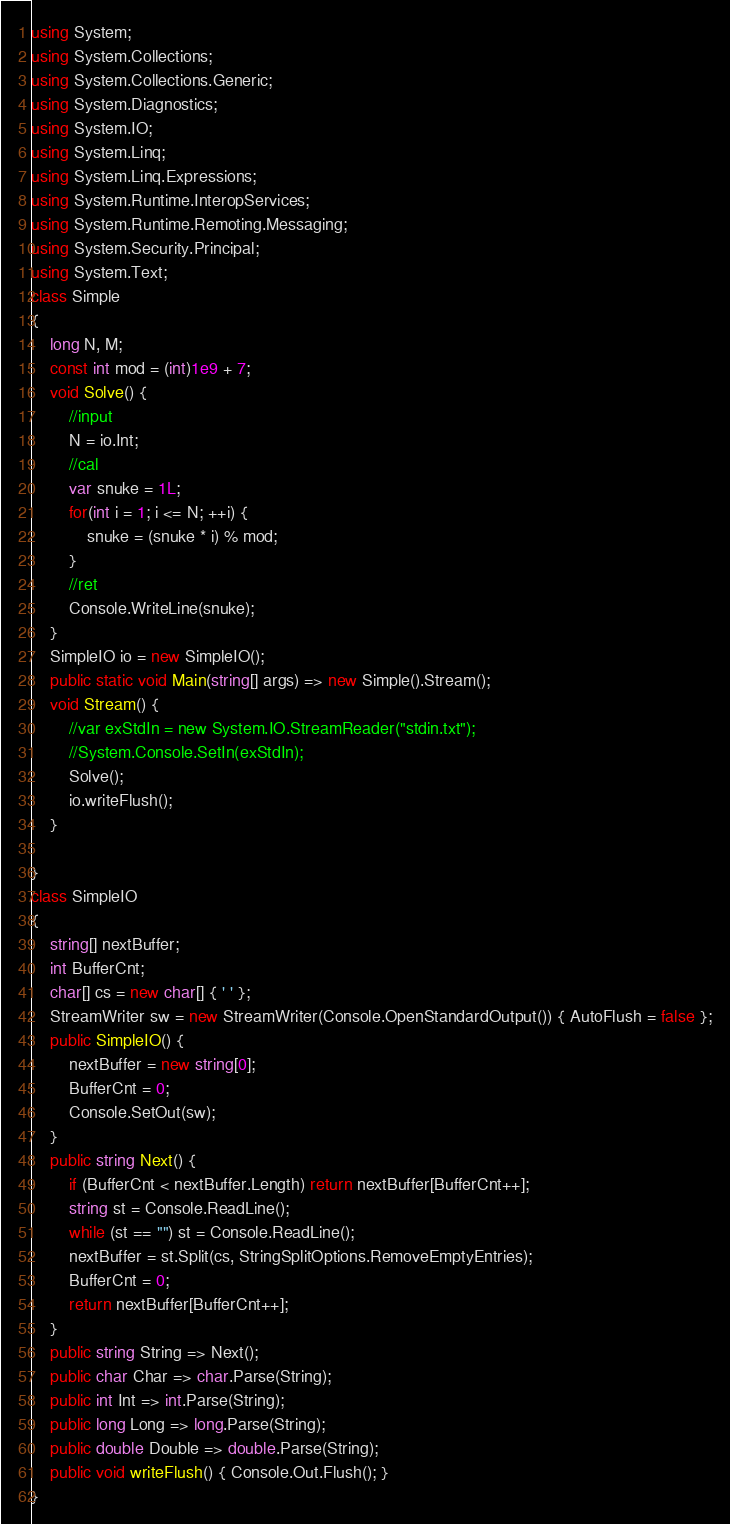Convert code to text. <code><loc_0><loc_0><loc_500><loc_500><_C#_>using System;
using System.Collections;
using System.Collections.Generic;
using System.Diagnostics;
using System.IO;
using System.Linq;
using System.Linq.Expressions;
using System.Runtime.InteropServices;
using System.Runtime.Remoting.Messaging;
using System.Security.Principal;
using System.Text;
class Simple
{
    long N, M;
    const int mod = (int)1e9 + 7;
    void Solve() {
        //input
        N = io.Int;
        //cal
        var snuke = 1L;
        for(int i = 1; i <= N; ++i) {
            snuke = (snuke * i) % mod;
        }
        //ret
        Console.WriteLine(snuke);
    }
    SimpleIO io = new SimpleIO();
    public static void Main(string[] args) => new Simple().Stream();
    void Stream() {
        //var exStdIn = new System.IO.StreamReader("stdin.txt");
        //System.Console.SetIn(exStdIn);
        Solve();
        io.writeFlush();
    }

}
class SimpleIO
{
    string[] nextBuffer;
    int BufferCnt;
    char[] cs = new char[] { ' ' };
    StreamWriter sw = new StreamWriter(Console.OpenStandardOutput()) { AutoFlush = false };
    public SimpleIO() {
        nextBuffer = new string[0];
        BufferCnt = 0;
        Console.SetOut(sw);
    }
    public string Next() {
        if (BufferCnt < nextBuffer.Length) return nextBuffer[BufferCnt++];
        string st = Console.ReadLine();
        while (st == "") st = Console.ReadLine();
        nextBuffer = st.Split(cs, StringSplitOptions.RemoveEmptyEntries);
        BufferCnt = 0;
        return nextBuffer[BufferCnt++];
    }
    public string String => Next();
    public char Char => char.Parse(String);
    public int Int => int.Parse(String);
    public long Long => long.Parse(String);
    public double Double => double.Parse(String);
    public void writeFlush() { Console.Out.Flush(); }
}
</code> 